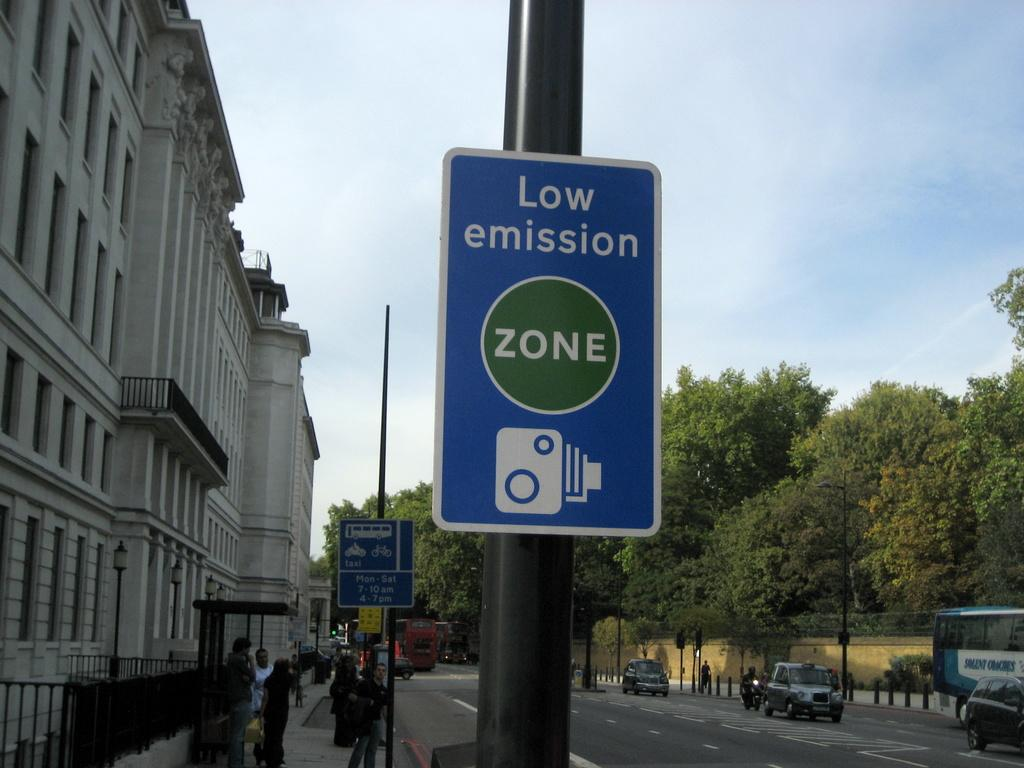<image>
Write a terse but informative summary of the picture. A sign for a Low Emission zone hangs on a street pole. 